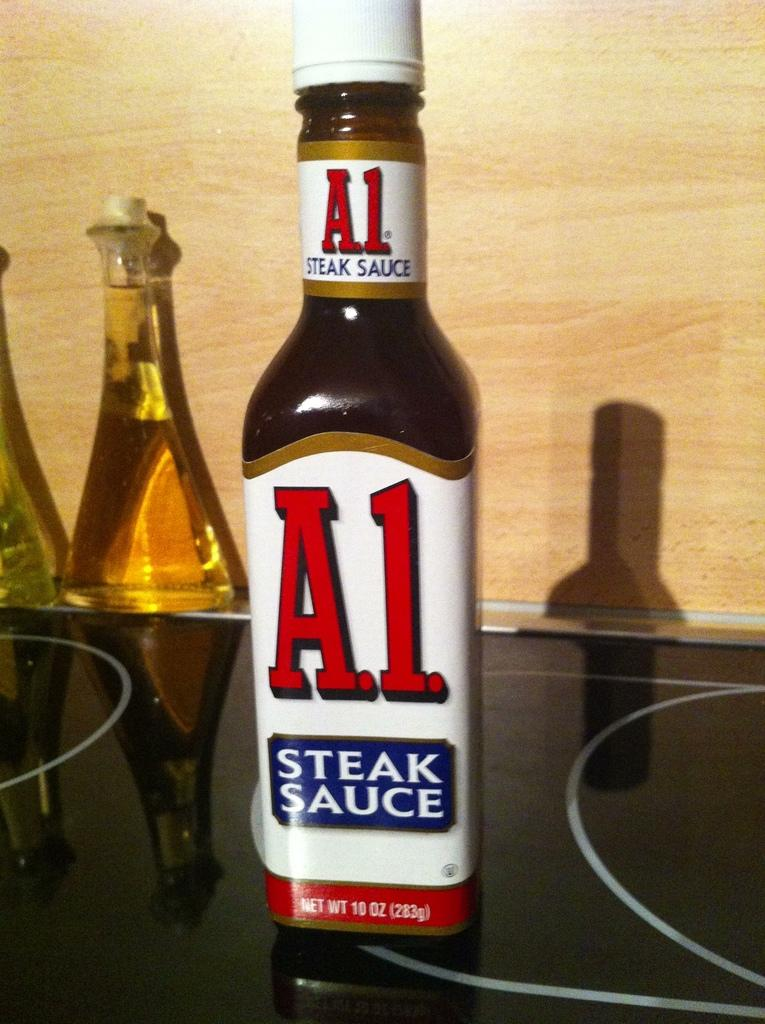<image>
Offer a succinct explanation of the picture presented. A 10 oz bottle of A.1. steak sauce sits on the table. 